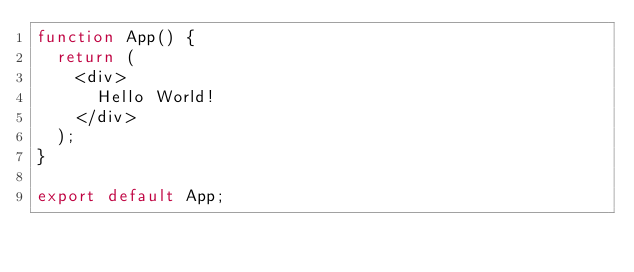Convert code to text. <code><loc_0><loc_0><loc_500><loc_500><_JavaScript_>function App() {
  return (
    <div>
      Hello World!
    </div>
  );
}

export default App;
</code> 